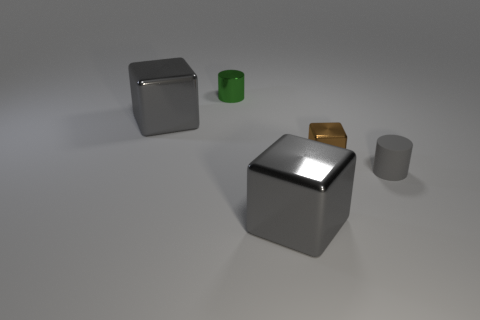There is another green object that is the same shape as the small matte thing; what is it made of?
Keep it short and to the point. Metal. Is there anything else that is made of the same material as the tiny gray cylinder?
Your answer should be very brief. No. The tiny green object that is the same material as the brown cube is what shape?
Make the answer very short. Cylinder. How many other tiny objects have the same shape as the gray rubber object?
Offer a very short reply. 1. There is a big gray metallic thing that is in front of the gray block that is behind the small block; what is its shape?
Your answer should be very brief. Cube. There is a cylinder that is behind the gray cylinder; does it have the same size as the small gray matte cylinder?
Keep it short and to the point. Yes. There is a metal block that is both right of the green metallic cylinder and behind the small gray matte cylinder; what size is it?
Offer a very short reply. Small. How many gray shiny objects are the same size as the gray rubber object?
Your answer should be compact. 0. How many gray cubes are in front of the tiny cylinder that is right of the green metal thing?
Your response must be concise. 1. Does the big shiny cube behind the tiny gray cylinder have the same color as the rubber cylinder?
Offer a very short reply. Yes. 